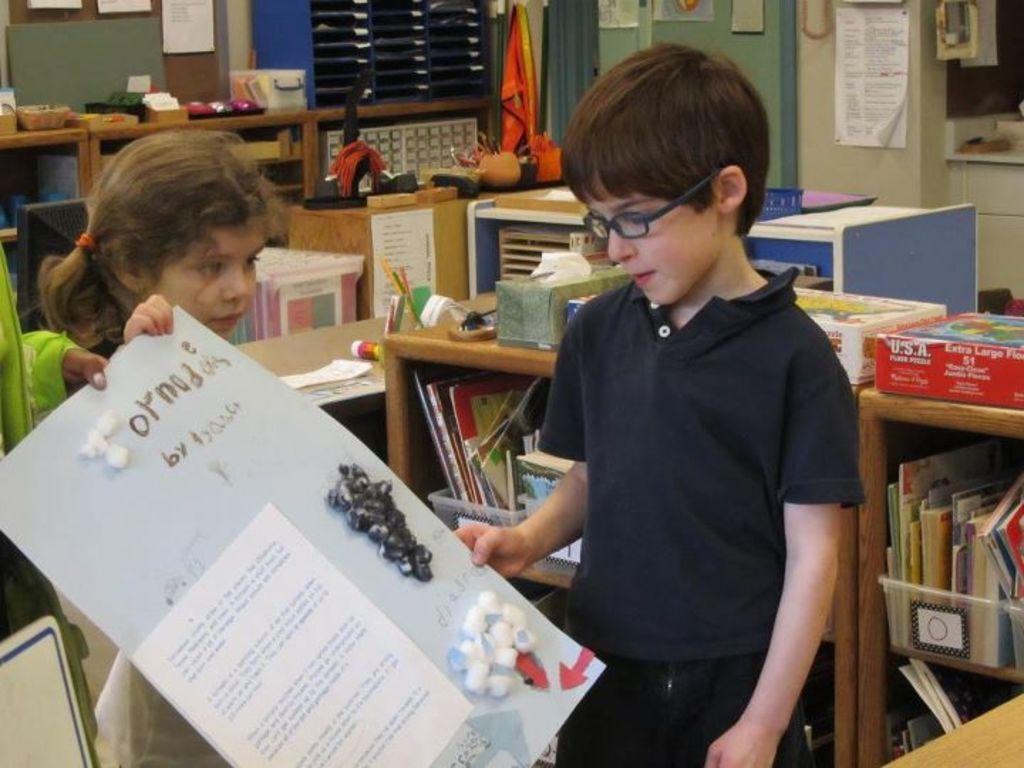Can you describe this image briefly? There is a small girl and a boy holding a poster in the foreground area of the image, there are bookshelves, it seems like a desk, other objects and posters in the background. 